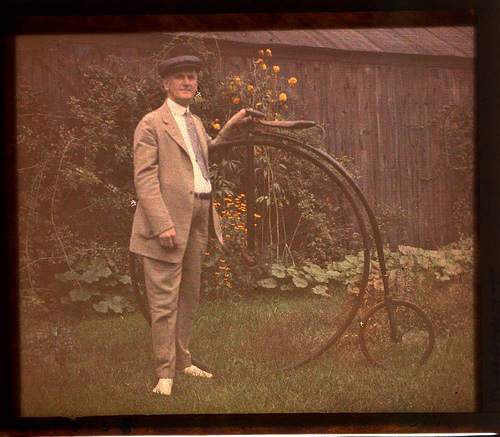<image>What fruit is most prominently featured here? It is ambiguous what fruit is most prominently featured in the image. It could be oranges, apples, berries, pumpkin or strawberries. What fruit is most prominently featured here? I am not sure what fruit is most prominently featured here. It could be oranges, berries, apples, or strawberries. 